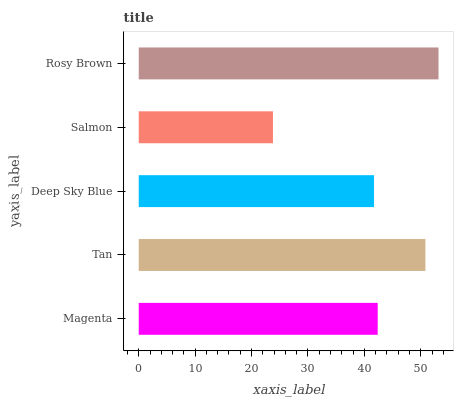Is Salmon the minimum?
Answer yes or no. Yes. Is Rosy Brown the maximum?
Answer yes or no. Yes. Is Tan the minimum?
Answer yes or no. No. Is Tan the maximum?
Answer yes or no. No. Is Tan greater than Magenta?
Answer yes or no. Yes. Is Magenta less than Tan?
Answer yes or no. Yes. Is Magenta greater than Tan?
Answer yes or no. No. Is Tan less than Magenta?
Answer yes or no. No. Is Magenta the high median?
Answer yes or no. Yes. Is Magenta the low median?
Answer yes or no. Yes. Is Salmon the high median?
Answer yes or no. No. Is Tan the low median?
Answer yes or no. No. 